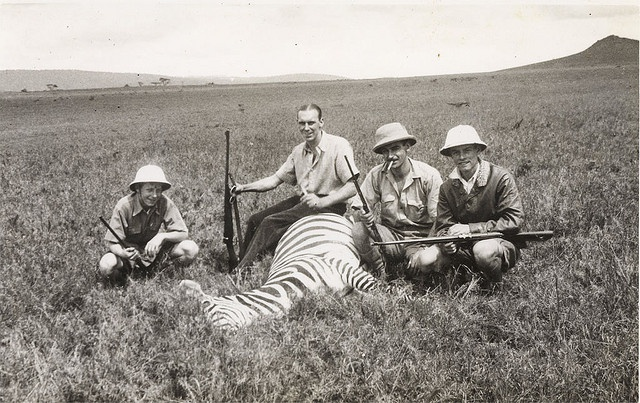Describe the objects in this image and their specific colors. I can see zebra in white, lightgray, darkgray, and gray tones, people in white, black, gray, lightgray, and darkgray tones, people in white, gray, darkgray, lightgray, and black tones, people in white, lightgray, gray, darkgray, and black tones, and people in white, black, lightgray, gray, and darkgray tones in this image. 